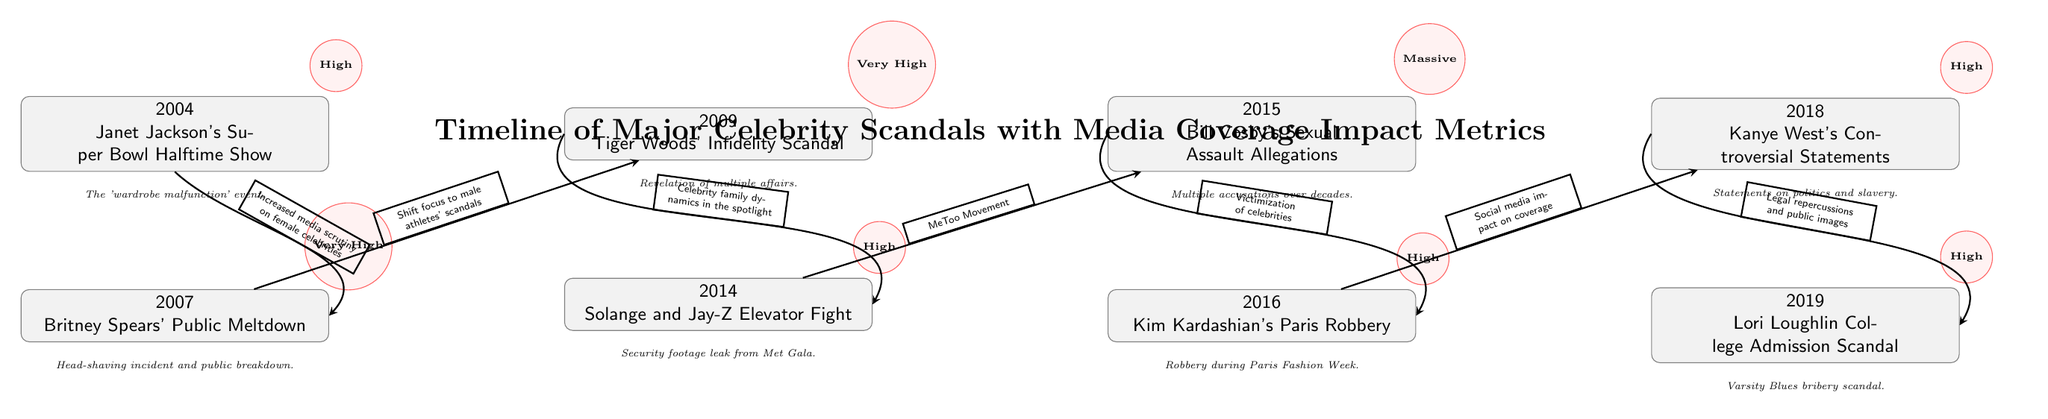What major incident is listed in 2004? The event associated with 2004 in the diagram is Janet Jackson's Super Bowl Halftime Show. This information is directly found in the first node on the timeline.
Answer: Janet Jackson's Super Bowl Halftime Show How many major celebrity scandals are represented in the diagram? The diagram shows a total of eight major celebrity scandals, as identified by the eight nodes representing each scandal from 2004 to 2019.
Answer: Eight What is the impact metric for the 2018 scandal involving Kanye West? According to the diagram, the impact metric for Kanye West's controversial statements in 2018 is categorized as High. This is stated in the node associated with the event for that year.
Answer: High What is the connection between the 2007 and 2009 events? The connection between the 2007 event (Britney Spears' Public Meltdown) and the 2009 event (Tiger Woods' Infidelity Scandal) indicates a shift in media focus to male athletes' scandals. This relationship is illustrated with an arrow showing the direction of influence.
Answer: Shift focus to male athletes' scandals Which scandal description mentions "Multiple accusations"? The description for the 2015 scandal involving Bill Cosby mentions "Multiple accusations over decades." This can be found directly beneath the event in the node for 2015.
Answer: Bill Cosby's Sexual Assault Allegations How does the diagram illustrate the impact of the MeToo movement? The diagram illustrates the impact of the MeToo movement by showing that it influenced the narrative from the Solange and Jay-Z Elevator Fight (2014) to the Bill Cosby's Sexual Assault Allegations (2015), marked by an arrow connecting these two events with a label.
Answer: MeToo Movement Which event's media coverage was impacted by social media, according to the diagram? The event whose media coverage was notably impacted by social media is Kim Kardashian's Paris Robbery in 2016, as indicated by the connection arrow leading to Kanye West's statements in 2018.
Answer: Kim Kardashian's Paris Robbery What is the impact level assigned to the 2009 scandal? The impact level assigned to the 2009 scandal, which involves Tiger Woods' infidelity, is categorized as Very High. This information is clearly labeled next to the 2009 event node.
Answer: Very High 